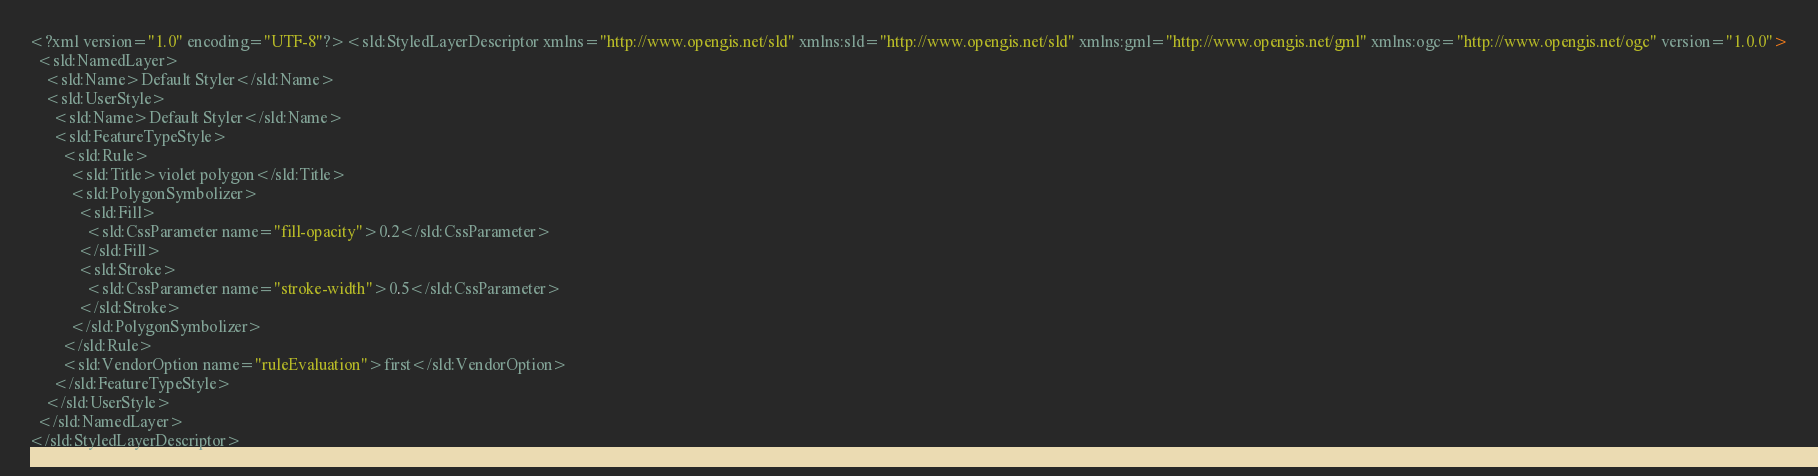Convert code to text. <code><loc_0><loc_0><loc_500><loc_500><_Scheme_><?xml version="1.0" encoding="UTF-8"?><sld:StyledLayerDescriptor xmlns="http://www.opengis.net/sld" xmlns:sld="http://www.opengis.net/sld" xmlns:gml="http://www.opengis.net/gml" xmlns:ogc="http://www.opengis.net/ogc" version="1.0.0">
  <sld:NamedLayer>
    <sld:Name>Default Styler</sld:Name>
    <sld:UserStyle>
      <sld:Name>Default Styler</sld:Name>
      <sld:FeatureTypeStyle>
        <sld:Rule>
          <sld:Title>violet polygon</sld:Title>
          <sld:PolygonSymbolizer>
            <sld:Fill>
              <sld:CssParameter name="fill-opacity">0.2</sld:CssParameter>
            </sld:Fill>
            <sld:Stroke>
              <sld:CssParameter name="stroke-width">0.5</sld:CssParameter>
            </sld:Stroke>
          </sld:PolygonSymbolizer>
        </sld:Rule>
        <sld:VendorOption name="ruleEvaluation">first</sld:VendorOption>
      </sld:FeatureTypeStyle>
    </sld:UserStyle>
  </sld:NamedLayer>
</sld:StyledLayerDescriptor>

</code> 